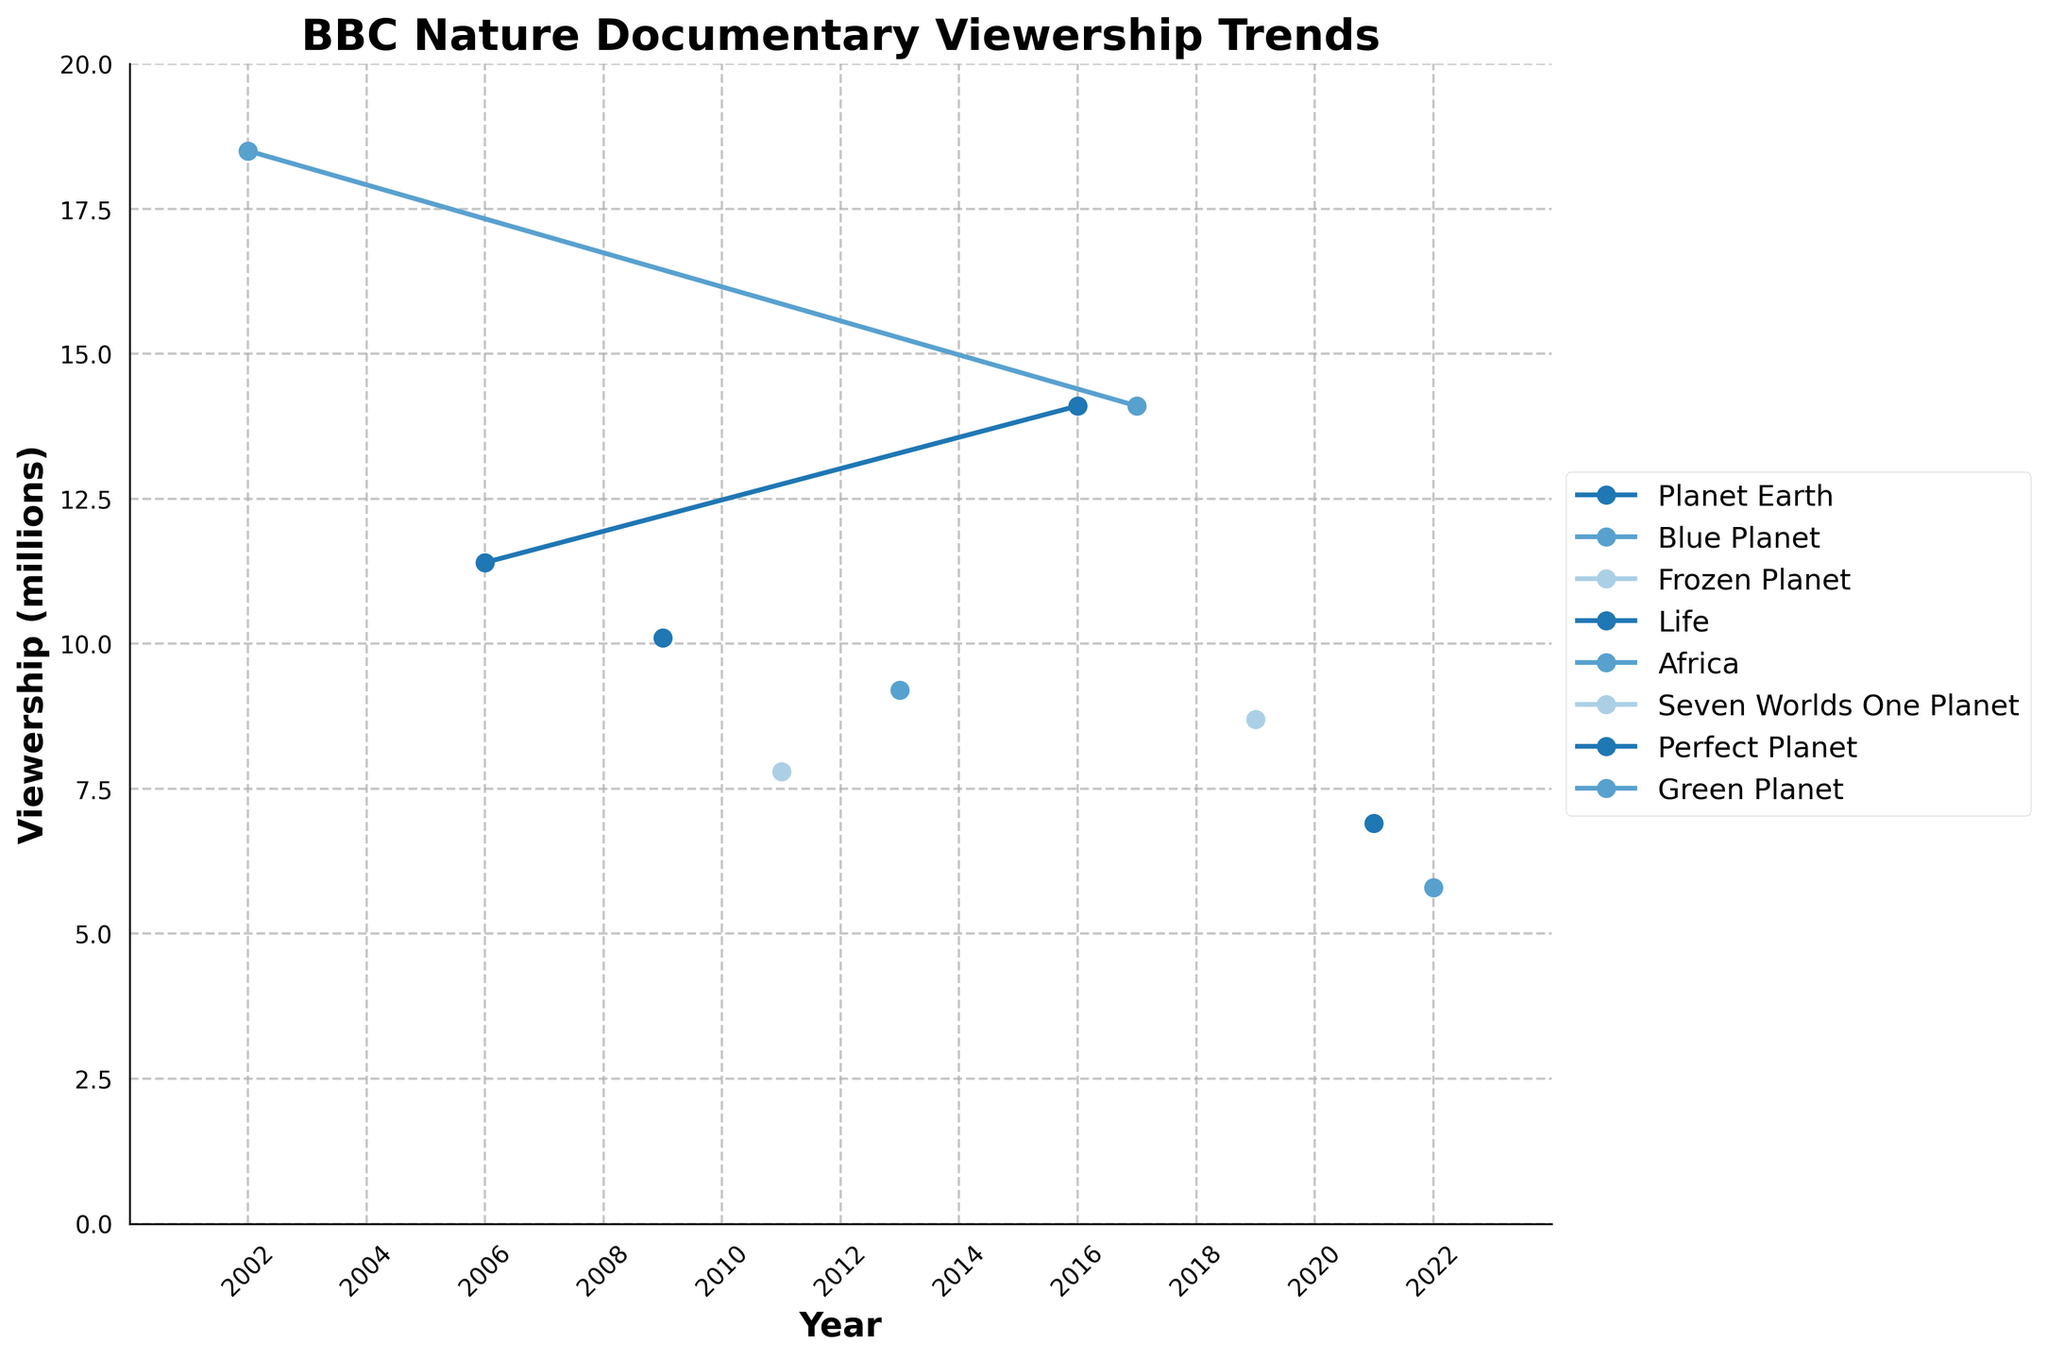Which documentary had the highest viewership in 2006? Look at the plot for 2006. "Planet Earth" has the highest viewership of 11.4 million.
Answer: Planet Earth Between "Blue Planet" and "Frozen Planet," which had a higher viewership in their initial releases? "Blue Planet" was released in 2002 with a viewership of 18.5 million. "Frozen Planet" was released in 2011 with a viewership of 7.8 million. Comparatively, "Blue Planet" had a higher initial viewership.
Answer: Blue Planet What is the total viewership for "Life" and "Africa"? "Life" in 2009 had 10.1 million, and "Africa" in 2013 had 9.2 million. Summing them gives 10.1 + 9.2 = 19.3 million total viewership.
Answer: 19.3 million Which documentary had the lowest viewership, and in what year? "Perfect Planet" had the lowest viewership with 6.9 million in 2021.
Answer: Perfect Planet in 2021 What trend can you observe in the viewership of "Planet Earth" from 2006 to 2016? "Planet Earth" had an initial viewership of 11.4 million in 2006, which increased to 14.1 million in 2016, indicating a rising trend.
Answer: Increasing trend Compare the viewership of "Seven Worlds One Planet" in 2019 to that of "Green Planet" in 2022. Which one had a higher viewership? "Seven Worlds One Planet" had an 8.7 million viewership in 2019, while "Green Planet" had 5.8 million in 2022. Therefore, "Seven Worlds One Planet" had a higher viewership.
Answer: Seven Worlds One Planet What's the average viewership over the years for "Blue Planet"? "Blue Planet" had viewerships of 18.5 million in 2002 and 14.1 million in 2017. Average is (18.5 + 14.1) / 2 = 16.3 million.
Answer: 16.3 million Which documentaries have seen a decline in viewership in their sequels or later series? Both "Planet Earth" and "Blue Planet" have seen slight declines in their subsequent viewership, with "Planet Earth" from 11.4 million to 14.1 million, and "Blue Planet" from 18.5 million to 14.1 million.
Answer: Planet Earth, Blue Planet How many years did it take for "Frozen Planet" to reach (or nearly reach) the viewership level of "Life" in 2009? "Frozen Planet" in 2011 had a viewership of 7.8 million, which is lower than "Life" in 2009 with 10.1 million. By comparing directly, it never reached the same viewership.
Answer: Never reached 